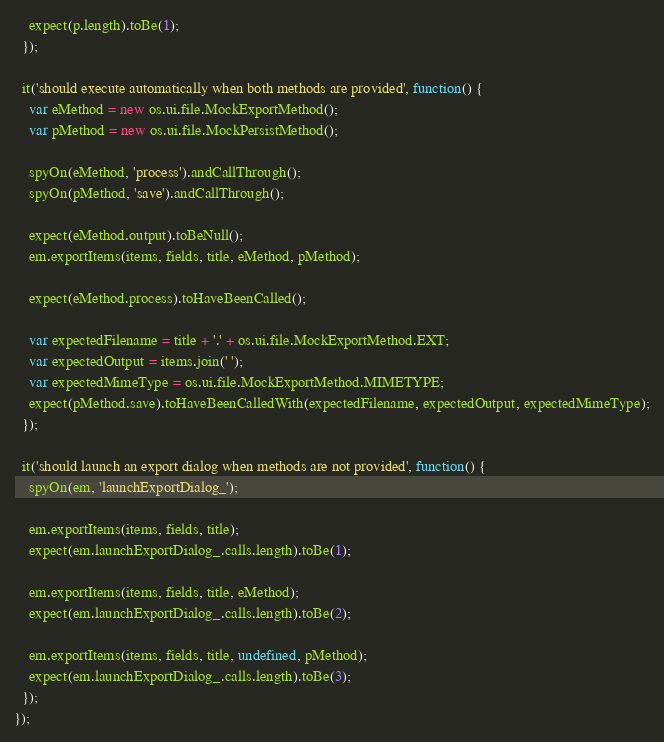<code> <loc_0><loc_0><loc_500><loc_500><_JavaScript_>    expect(p.length).toBe(1);
  });

  it('should execute automatically when both methods are provided', function() {
    var eMethod = new os.ui.file.MockExportMethod();
    var pMethod = new os.ui.file.MockPersistMethod();

    spyOn(eMethod, 'process').andCallThrough();
    spyOn(pMethod, 'save').andCallThrough();

    expect(eMethod.output).toBeNull();
    em.exportItems(items, fields, title, eMethod, pMethod);

    expect(eMethod.process).toHaveBeenCalled();

    var expectedFilename = title + '.' + os.ui.file.MockExportMethod.EXT;
    var expectedOutput = items.join(' ');
    var expectedMimeType = os.ui.file.MockExportMethod.MIMETYPE;
    expect(pMethod.save).toHaveBeenCalledWith(expectedFilename, expectedOutput, expectedMimeType);
  });

  it('should launch an export dialog when methods are not provided', function() {
    spyOn(em, 'launchExportDialog_');

    em.exportItems(items, fields, title);
    expect(em.launchExportDialog_.calls.length).toBe(1);

    em.exportItems(items, fields, title, eMethod);
    expect(em.launchExportDialog_.calls.length).toBe(2);

    em.exportItems(items, fields, title, undefined, pMethod);
    expect(em.launchExportDialog_.calls.length).toBe(3);
  });
});
</code> 